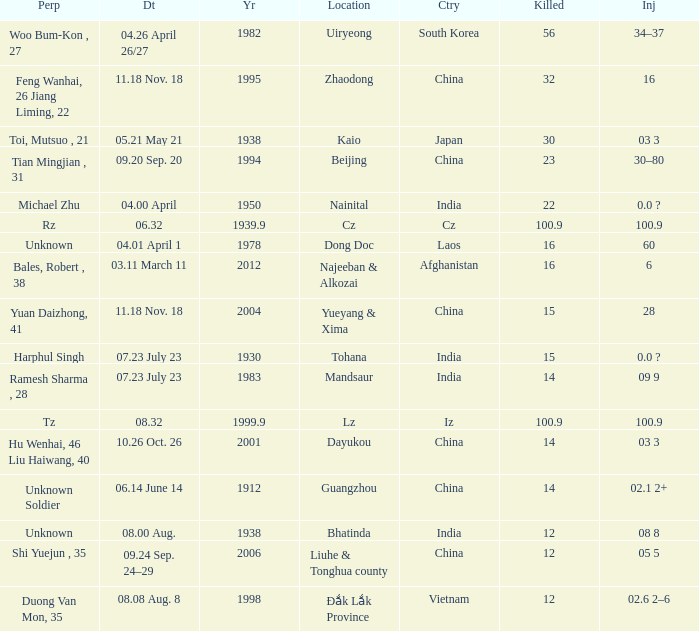Could you parse the entire table? {'header': ['Perp', 'Dt', 'Yr', 'Location', 'Ctry', 'Killed', 'Inj'], 'rows': [['Woo Bum-Kon , 27', '04.26 April 26/27', '1982', 'Uiryeong', 'South Korea', '56', '34–37'], ['Feng Wanhai, 26 Jiang Liming, 22', '11.18 Nov. 18', '1995', 'Zhaodong', 'China', '32', '16'], ['Toi, Mutsuo , 21', '05.21 May 21', '1938', 'Kaio', 'Japan', '30', '03 3'], ['Tian Mingjian , 31', '09.20 Sep. 20', '1994', 'Beijing', 'China', '23', '30–80'], ['Michael Zhu', '04.00 April', '1950', 'Nainital', 'India', '22', '0.0 ?'], ['Rz', '06.32', '1939.9', 'Cz', 'Cz', '100.9', '100.9'], ['Unknown', '04.01 April 1', '1978', 'Dong Doc', 'Laos', '16', '60'], ['Bales, Robert , 38', '03.11 March 11', '2012', 'Najeeban & Alkozai', 'Afghanistan', '16', '6'], ['Yuan Daizhong, 41', '11.18 Nov. 18', '2004', 'Yueyang & Xima', 'China', '15', '28'], ['Harphul Singh', '07.23 July 23', '1930', 'Tohana', 'India', '15', '0.0 ?'], ['Ramesh Sharma , 28', '07.23 July 23', '1983', 'Mandsaur', 'India', '14', '09 9'], ['Tz', '08.32', '1999.9', 'Lz', 'Iz', '100.9', '100.9'], ['Hu Wenhai, 46 Liu Haiwang, 40', '10.26 Oct. 26', '2001', 'Dayukou', 'China', '14', '03 3'], ['Unknown Soldier', '06.14 June 14', '1912', 'Guangzhou', 'China', '14', '02.1 2+'], ['Unknown', '08.00 Aug.', '1938', 'Bhatinda', 'India', '12', '08 8'], ['Shi Yuejun , 35', '09.24 Sep. 24–29', '2006', 'Liuhe & Tonghua county', 'China', '12', '05 5'], ['Duong Van Mon, 35', '08.08 Aug. 8', '1998', 'Đắk Lắk Province', 'Vietnam', '12', '02.6 2–6']]} What is damaged, when nation is "afghanistan"? 6.0. 